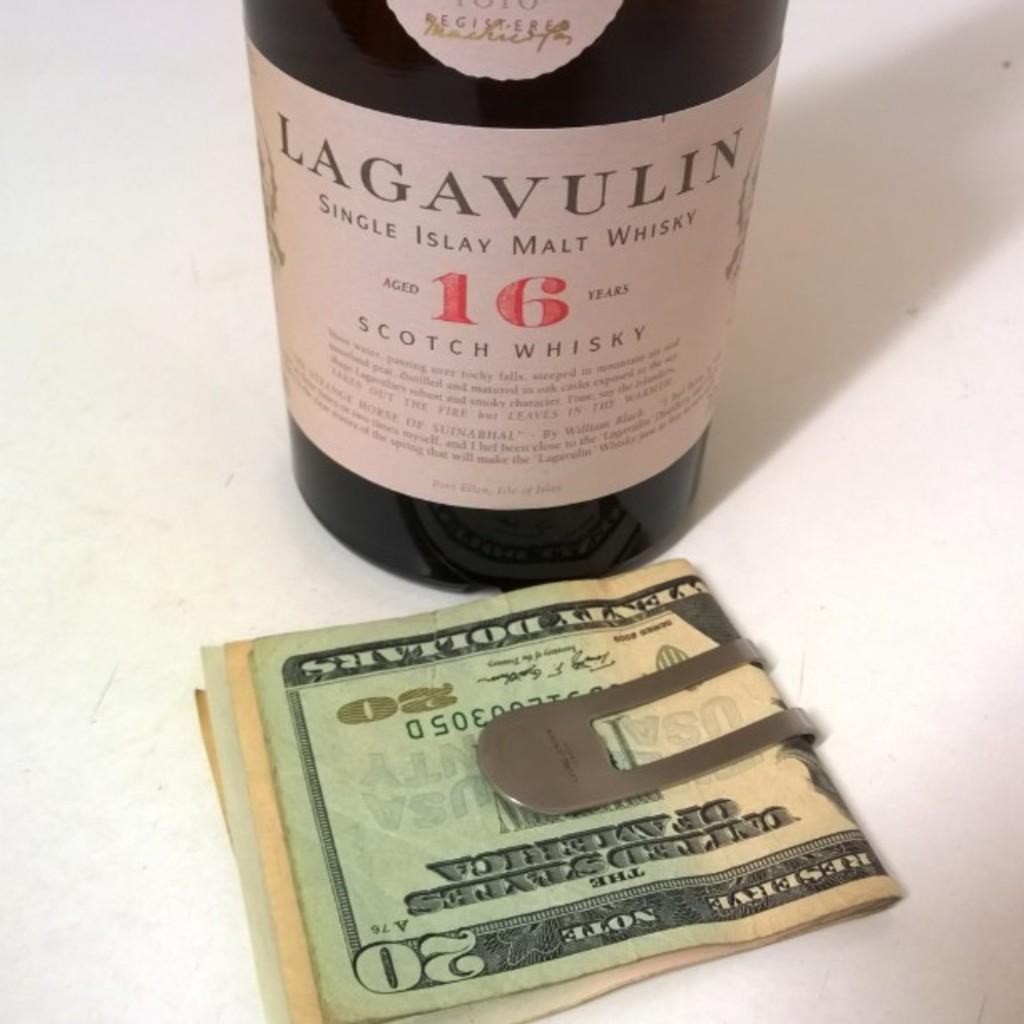What bill is on top?
Provide a short and direct response. 20. 